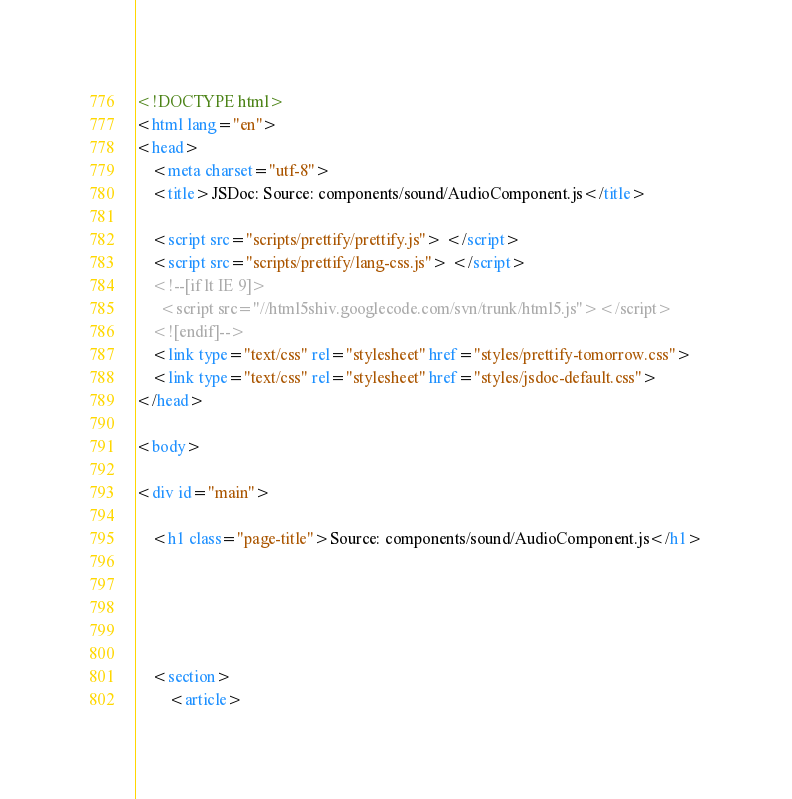Convert code to text. <code><loc_0><loc_0><loc_500><loc_500><_HTML_><!DOCTYPE html>
<html lang="en">
<head>
    <meta charset="utf-8">
    <title>JSDoc: Source: components/sound/AudioComponent.js</title>
    
    <script src="scripts/prettify/prettify.js"> </script>
    <script src="scripts/prettify/lang-css.js"> </script>
    <!--[if lt IE 9]>
      <script src="//html5shiv.googlecode.com/svn/trunk/html5.js"></script>
    <![endif]-->
    <link type="text/css" rel="stylesheet" href="styles/prettify-tomorrow.css">
    <link type="text/css" rel="stylesheet" href="styles/jsdoc-default.css">
</head>

<body>

<div id="main">
    
    <h1 class="page-title">Source: components/sound/AudioComponent.js</h1>
    
    


    
    <section>
        <article></code> 